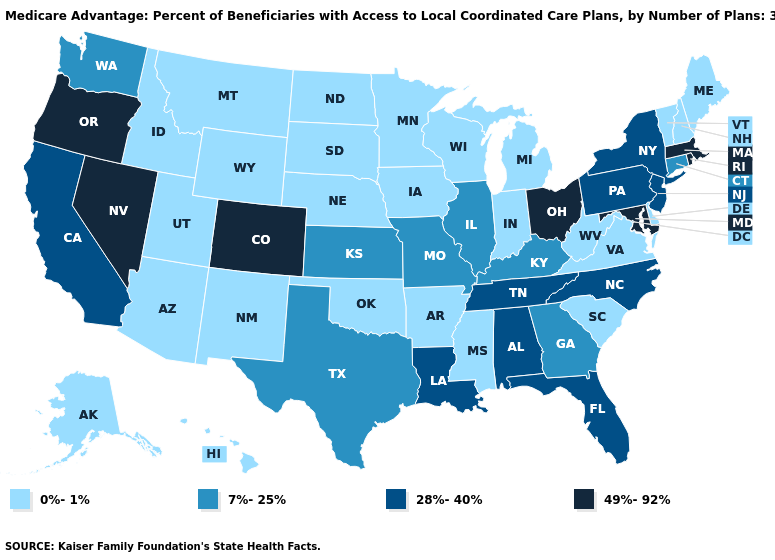What is the value of Arizona?
Keep it brief. 0%-1%. What is the lowest value in states that border New Mexico?
Answer briefly. 0%-1%. Which states have the highest value in the USA?
Answer briefly. Colorado, Massachusetts, Maryland, Nevada, Ohio, Oregon, Rhode Island. Which states have the lowest value in the Northeast?
Short answer required. Maine, New Hampshire, Vermont. Name the states that have a value in the range 28%-40%?
Concise answer only. Alabama, California, Florida, Louisiana, North Carolina, New Jersey, New York, Pennsylvania, Tennessee. Does Kansas have a higher value than Maine?
Write a very short answer. Yes. What is the value of South Carolina?
Quick response, please. 0%-1%. How many symbols are there in the legend?
Quick response, please. 4. Among the states that border Alabama , which have the lowest value?
Short answer required. Mississippi. Does Kentucky have the highest value in the USA?
Concise answer only. No. What is the lowest value in the South?
Answer briefly. 0%-1%. What is the value of Mississippi?
Quick response, please. 0%-1%. What is the lowest value in the USA?
Keep it brief. 0%-1%. Among the states that border New Hampshire , which have the lowest value?
Quick response, please. Maine, Vermont. Which states have the lowest value in the MidWest?
Give a very brief answer. Iowa, Indiana, Michigan, Minnesota, North Dakota, Nebraska, South Dakota, Wisconsin. 